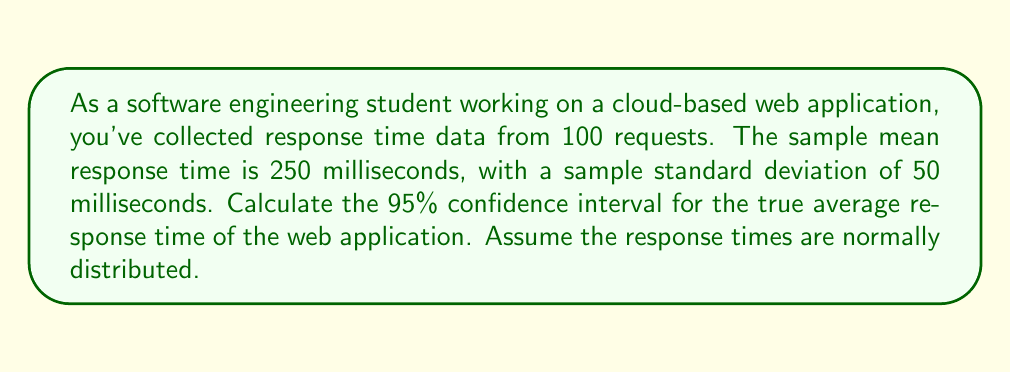Solve this math problem. To calculate the confidence interval, we'll use the formula:

$$ \text{CI} = \bar{x} \pm t_{\alpha/2, n-1} \cdot \frac{s}{\sqrt{n}} $$

Where:
- $\bar{x}$ is the sample mean (250 ms)
- $s$ is the sample standard deviation (50 ms)
- $n$ is the sample size (100)
- $t_{\alpha/2, n-1}$ is the t-value for a 95% confidence interval with 99 degrees of freedom

Steps:
1. Find the t-value: For a 95% CI with 99 degrees of freedom, $t_{0.025, 99} \approx 1.984$ (you can use a t-table or Python's scipy.stats.t.ppf function)

2. Calculate the standard error of the mean:
   $$ SE = \frac{s}{\sqrt{n}} = \frac{50}{\sqrt{100}} = 5 $$

3. Calculate the margin of error:
   $$ ME = t_{\alpha/2, n-1} \cdot SE = 1.984 \cdot 5 = 9.92 $$

4. Calculate the confidence interval:
   $$ \text{CI} = 250 \pm 9.92 $$

5. Express the final result:
   $$ \text{CI} = (240.08, 259.92) $$

This means we can be 95% confident that the true average response time of the web application falls between 240.08 ms and 259.92 ms.
Answer: The 95% confidence interval for the true average response time is (240.08 ms, 259.92 ms). 